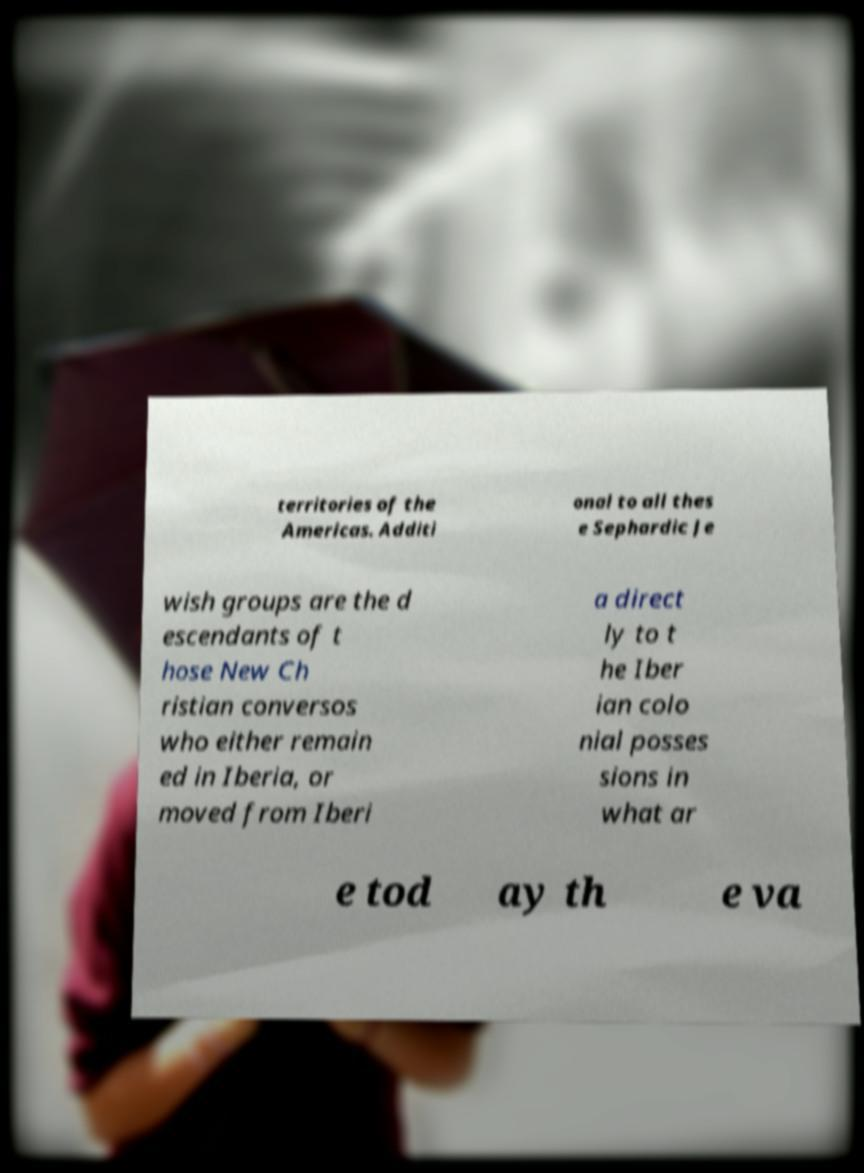Please identify and transcribe the text found in this image. territories of the Americas. Additi onal to all thes e Sephardic Je wish groups are the d escendants of t hose New Ch ristian conversos who either remain ed in Iberia, or moved from Iberi a direct ly to t he Iber ian colo nial posses sions in what ar e tod ay th e va 